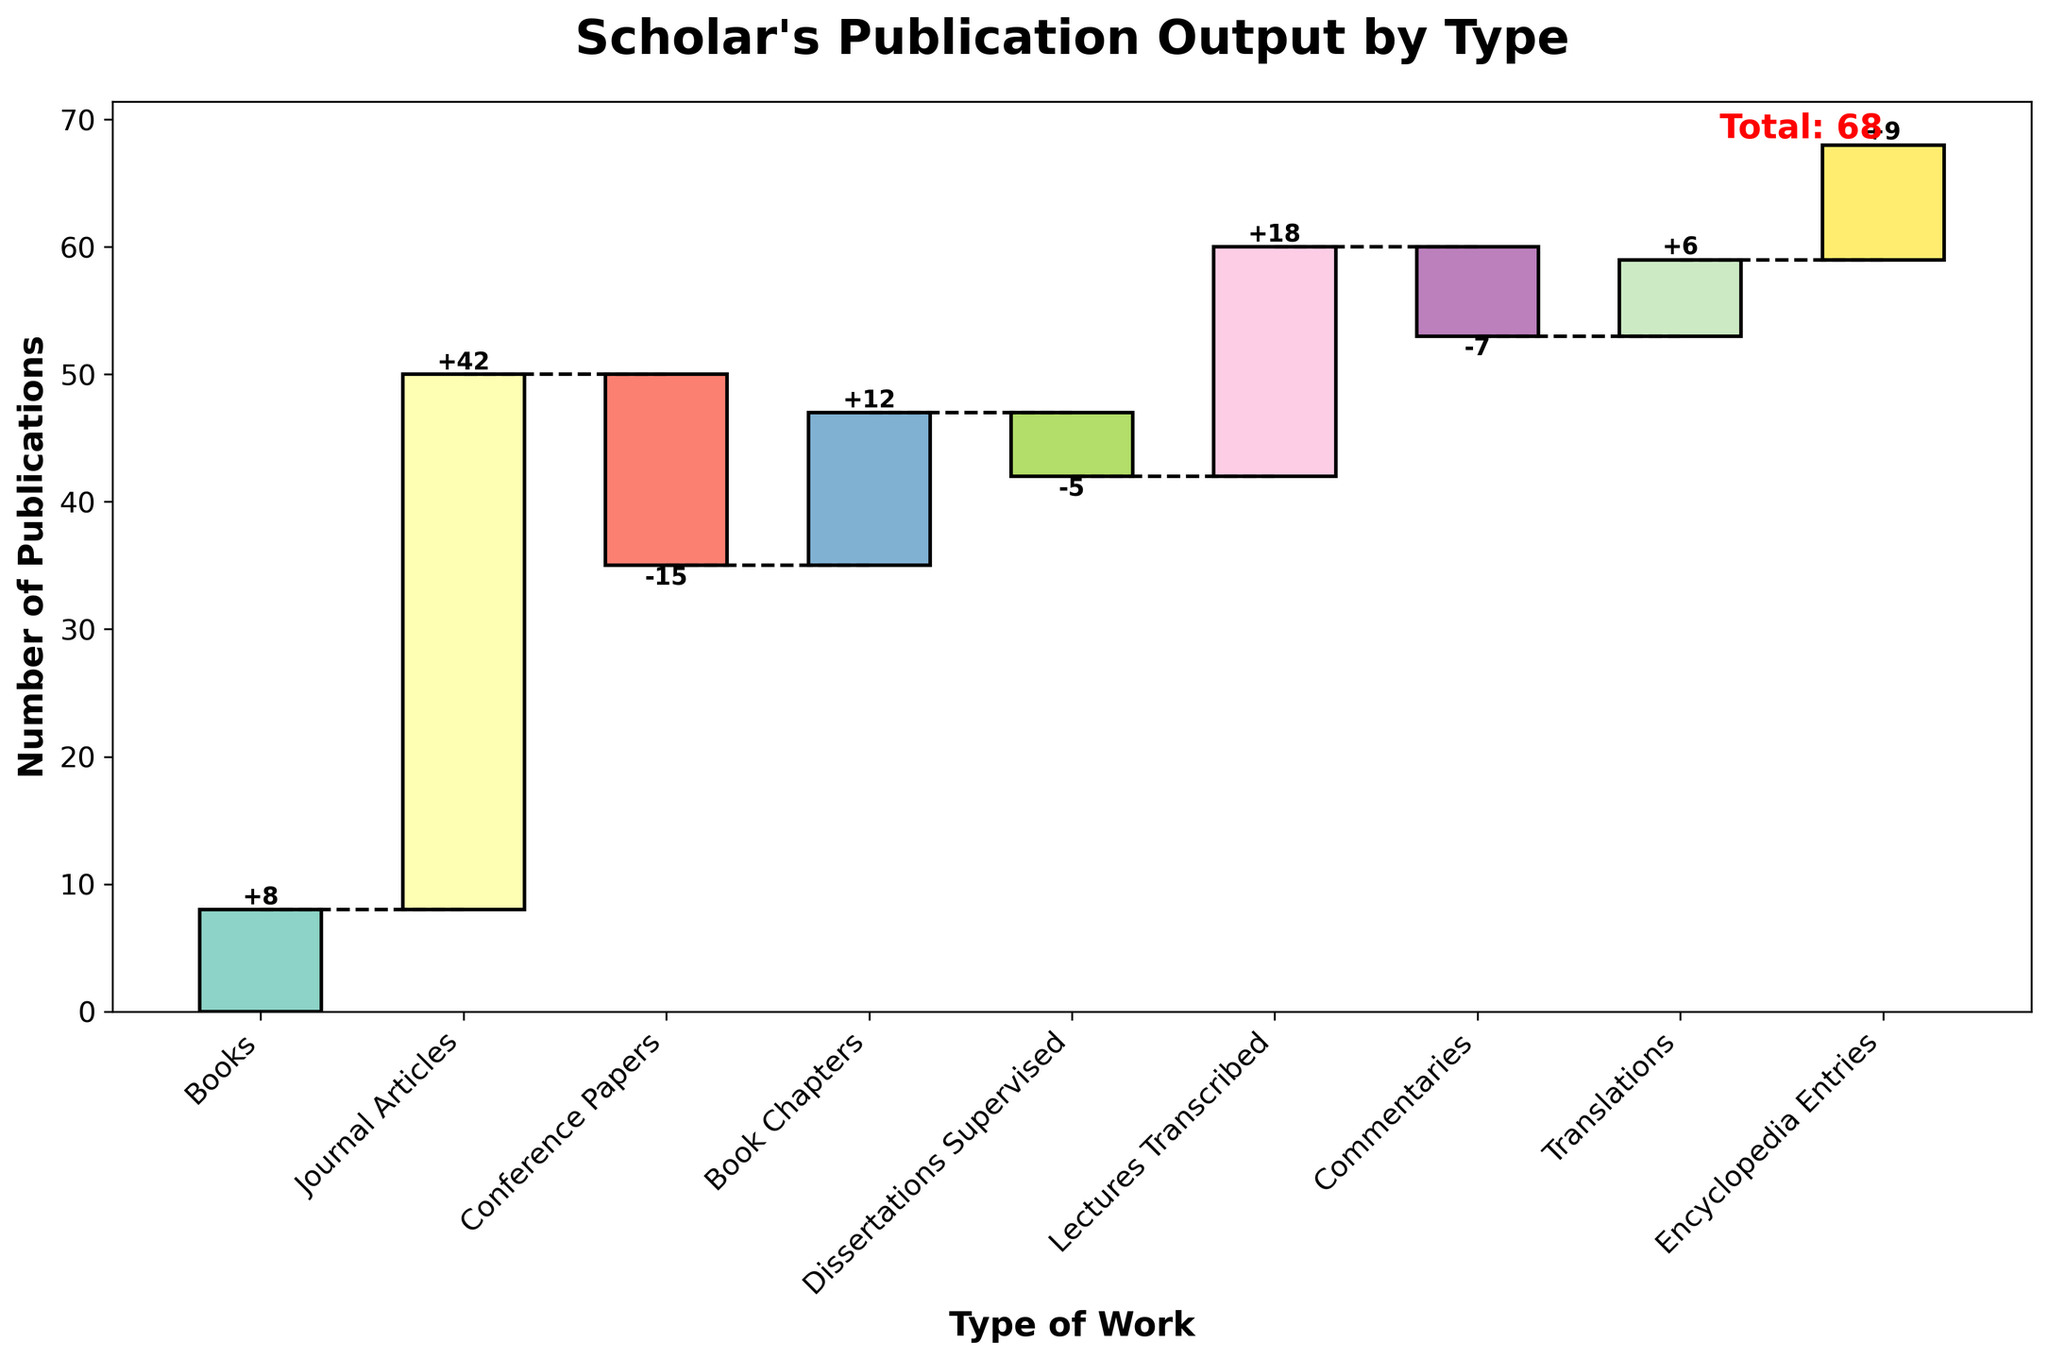What is the title of the waterfall chart? The title is typically at the top of the chart and gives a brief description of the content. In this case, it should be describing the scholar's publication output by type.
Answer: Scholar's Publication Output by Type How many books has the scholar published according to the chart? The values for each type of work are labeled on the bars in the chart. The bar labeled 'Books' will provide this information.
Answer: 8 What is the total number of publications or works documented in the chart? The total number is typically found at the end of the waterfall chart and may be highlighted or noted specifically.
Answer: 68 Which type of work had the highest number of publications? By observing the heights of the bars, the category with the tallest positive value is the one with the highest number of publications.
Answer: Journal Articles What is the net change in the scholar’s publication count due to conference papers and dissertations supervised? Sum the values of Conference Papers and Dissertations Supervised (-15 + -5).
Answer: -20 How do the number of book chapters compare to translations? Look at the values for Book Chapters and Translations to compare them directly.
Answer: There are 6 more book chapters than translations (12 vs. 6) How does the number of commentaries affect the total publication count? Identify the value for Commentaries and note its impact (positive or negative) on the cumulative total.
Answer: It decreases the total by 7 What is the contribution of encyclopedia entries to the scholar's total number of works? The value of Encyclopedia Entries is directly looked up from the respective bar and added to the cumulative total.
Answer: 9 Which category has the least number of publications, and what is its quantity? By comparing the values representing each type of work, identify the smallest value.
Answer: Commentaries, -7 How many types of works have a negative value, and what are they? Observe the number of bars with values below zero and list them.
Answer: 3 types: Conference Papers (-15), Dissertations Supervised (-5), and Commentaries (-7) 